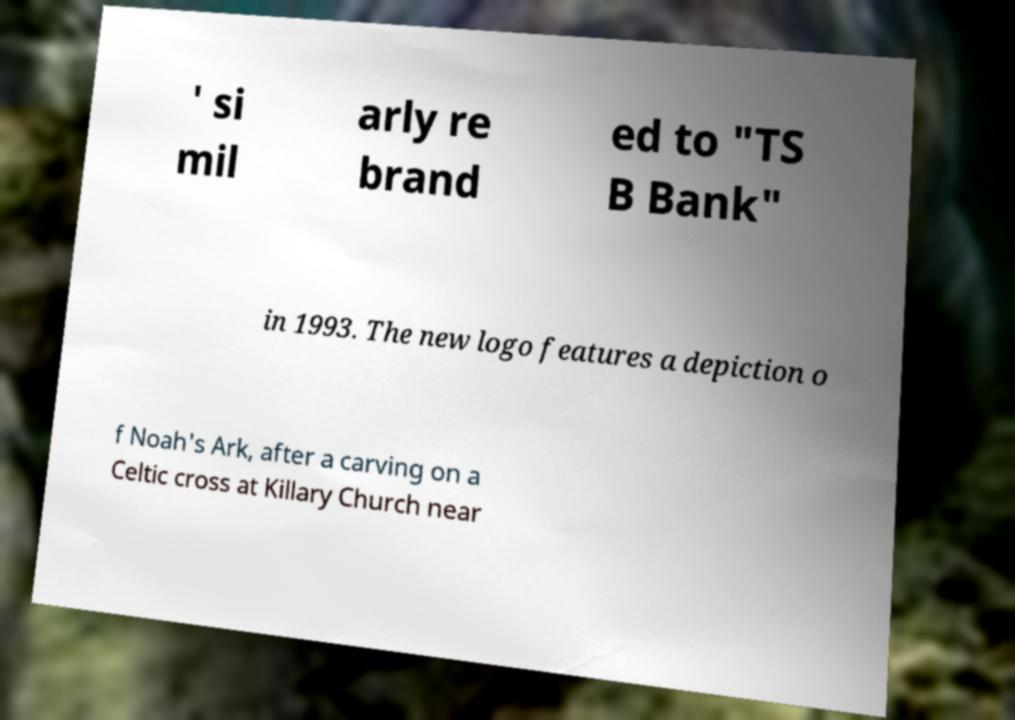For documentation purposes, I need the text within this image transcribed. Could you provide that? ' si mil arly re brand ed to "TS B Bank" in 1993. The new logo features a depiction o f Noah's Ark, after a carving on a Celtic cross at Killary Church near 